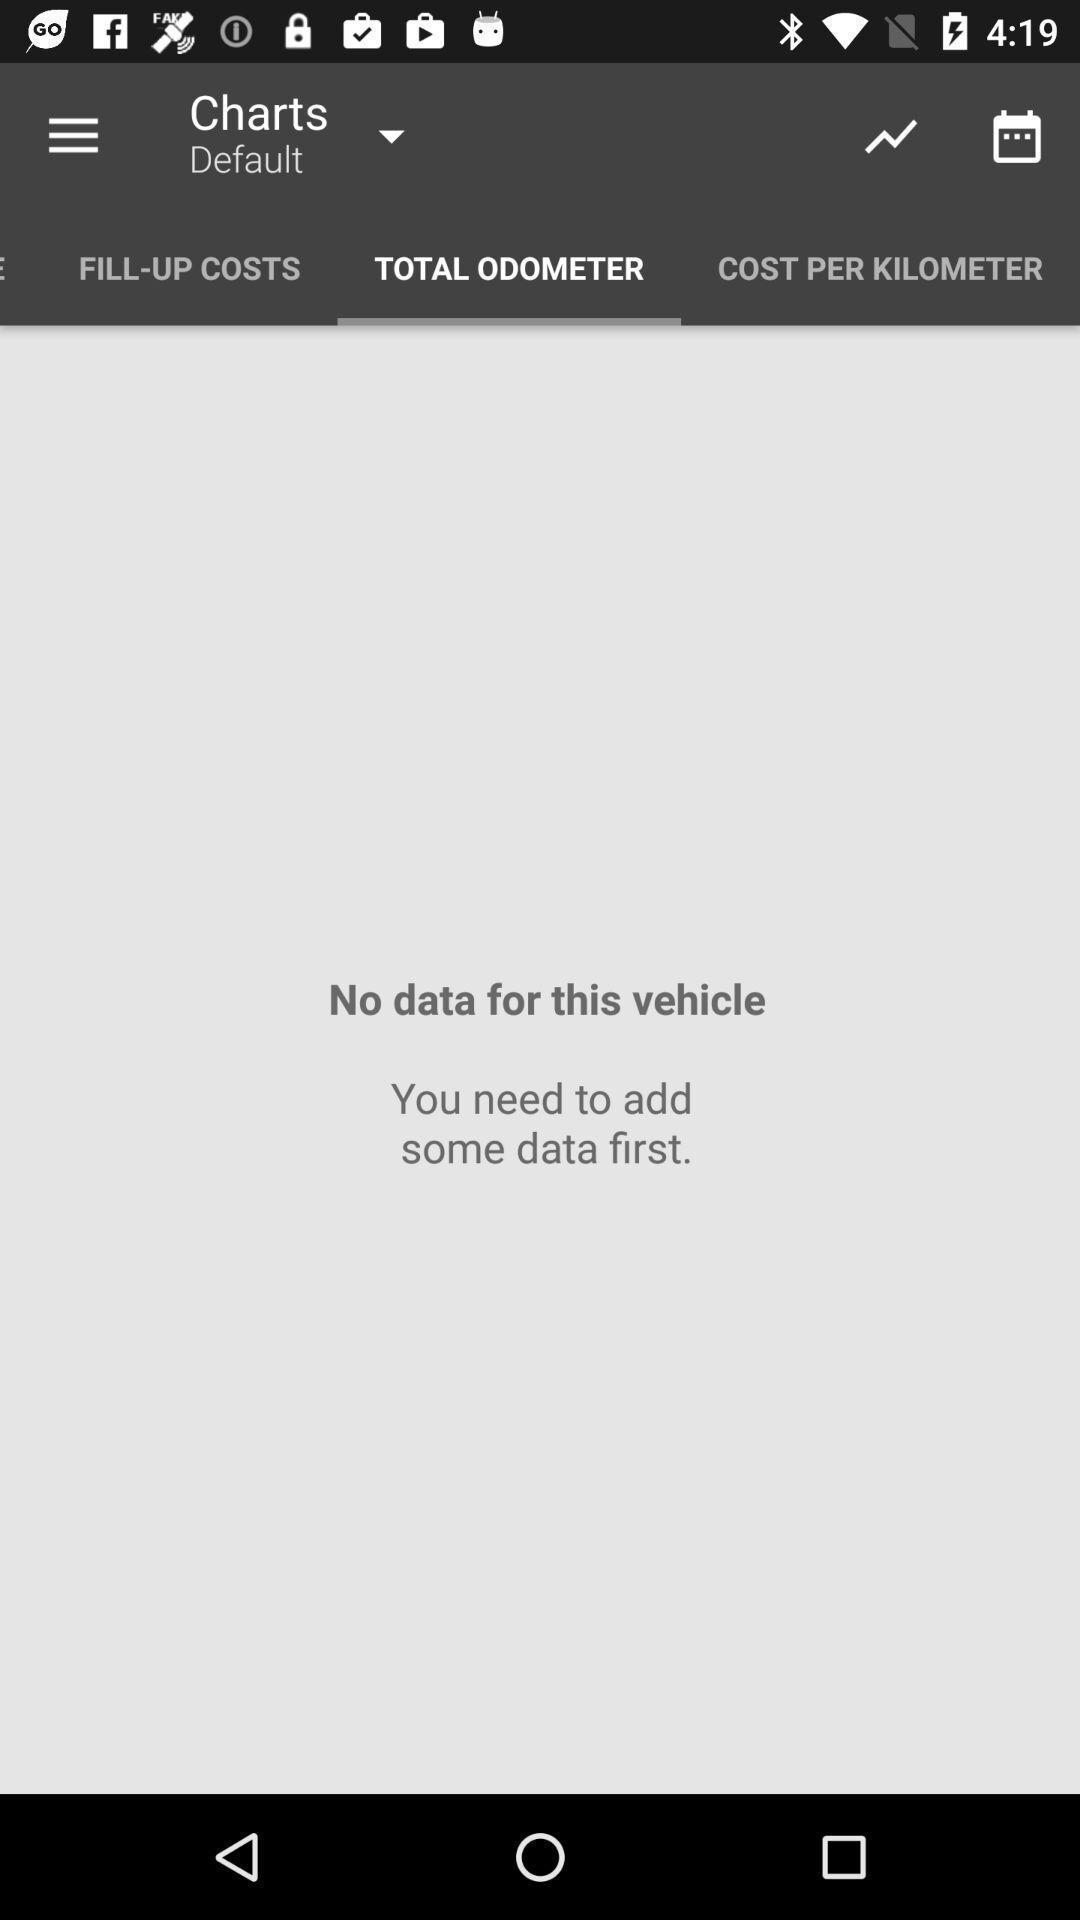Provide a textual representation of this image. Page displaying options in chart. 